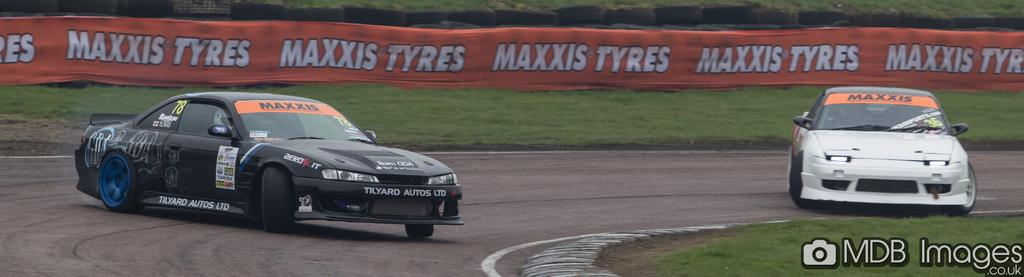How many cars are on the road in the image? There are two cars on the road in the image. What type of surface is visible in the image? There is grass on the surface in the image. What can be seen in the background of the image? There is a banner in the background of the image. What else is visible behind the banner? There are tires visible behind the banner. What type of dinosaur is visible in the image? There are no dinosaurs present in the image. How many toes can be seen on the dinosaur's foot in the image? There is no dinosaur in the image, so it is not possible to determine the number of toes on its foot. 